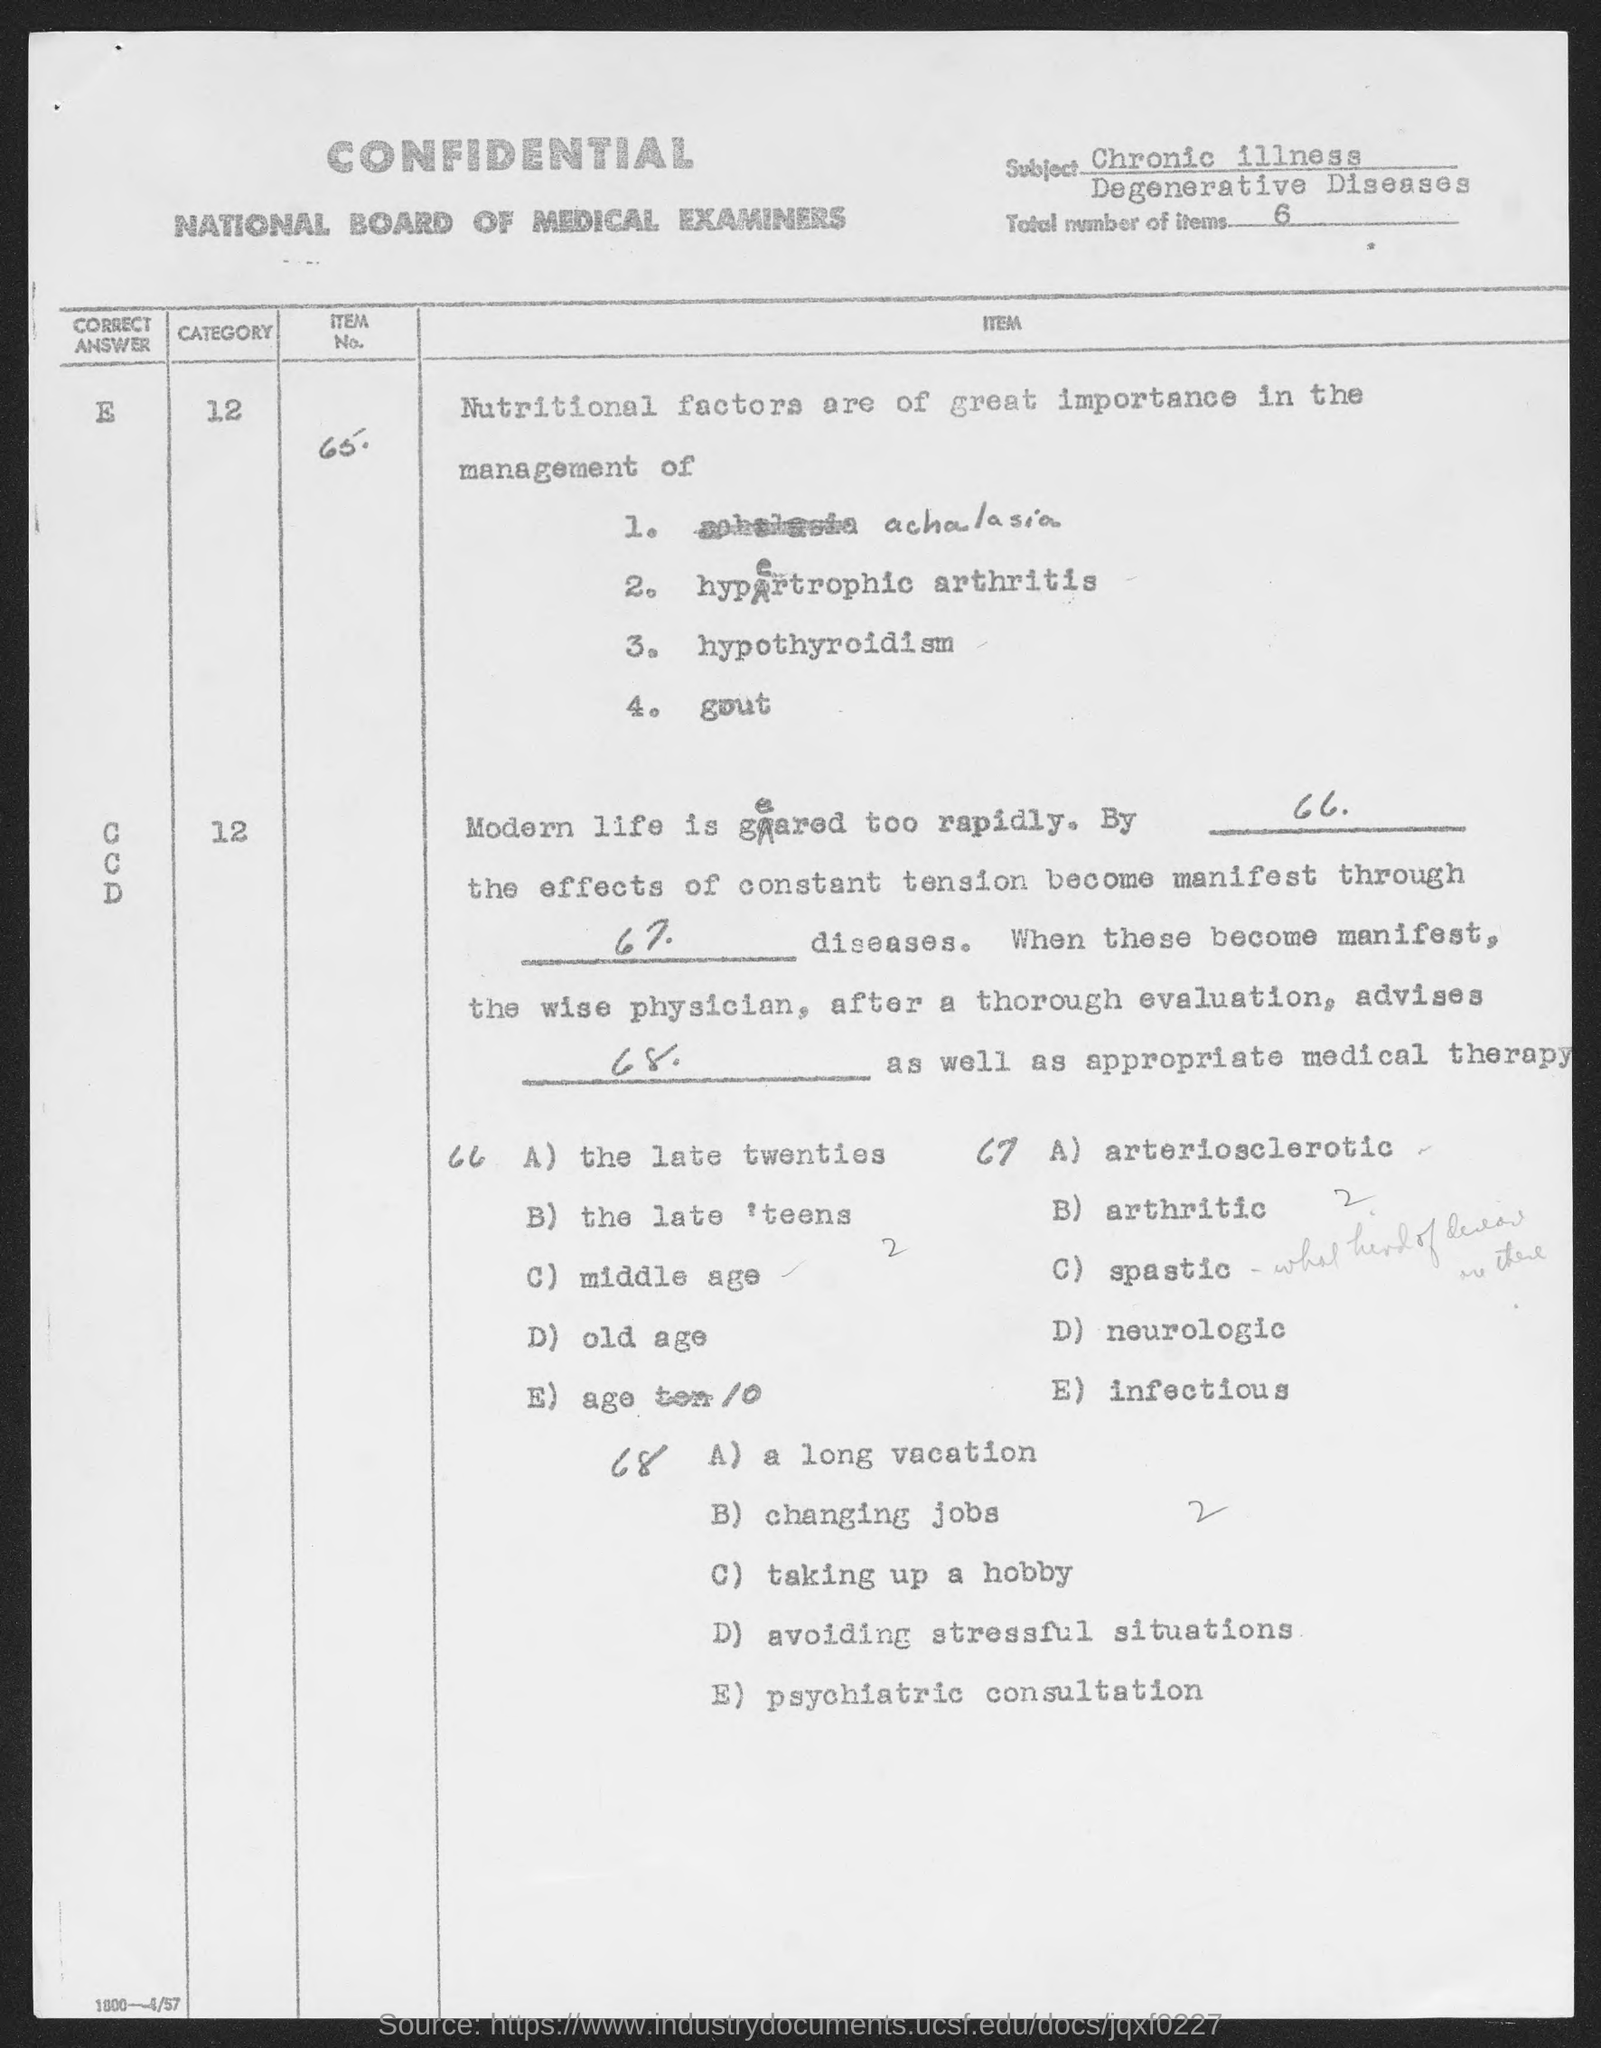What is the subject?
Your answer should be very brief. Chronic illness degenerative diseases. What are the total number of items?
Provide a succinct answer. 6. 